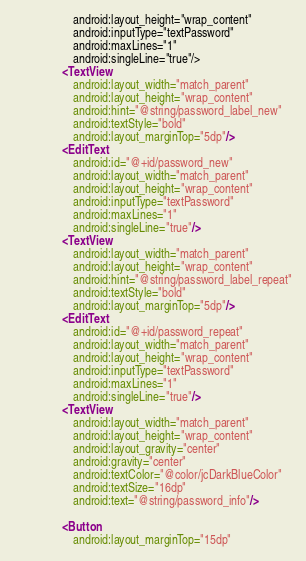<code> <loc_0><loc_0><loc_500><loc_500><_XML_>                    android:layout_height="wrap_content"
                    android:inputType="textPassword"
                    android:maxLines="1"
                    android:singleLine="true"/>
                <TextView
                    android:layout_width="match_parent"
                    android:layout_height="wrap_content"
                    android:hint="@string/password_label_new"
                    android:textStyle="bold"
                    android:layout_marginTop="5dp"/>
                <EditText
                    android:id="@+id/password_new"
                    android:layout_width="match_parent"
                    android:layout_height="wrap_content"
                    android:inputType="textPassword"
                    android:maxLines="1"
                    android:singleLine="true"/>
                <TextView
                    android:layout_width="match_parent"
                    android:layout_height="wrap_content"
                    android:hint="@string/password_label_repeat"
                    android:textStyle="bold"
                    android:layout_marginTop="5dp"/>
                <EditText
                    android:id="@+id/password_repeat"
                    android:layout_width="match_parent"
                    android:layout_height="wrap_content"
                    android:inputType="textPassword"
                    android:maxLines="1"
                    android:singleLine="true"/>
                <TextView
                    android:layout_width="match_parent"
                    android:layout_height="wrap_content"
                    android:layout_gravity="center"
                    android:gravity="center"
                    android:textColor="@color/jcDarkBlueColor"
                    android:textSize="16dp"
                    android:text="@string/password_info"/>

                <Button
                    android:layout_marginTop="15dp"</code> 